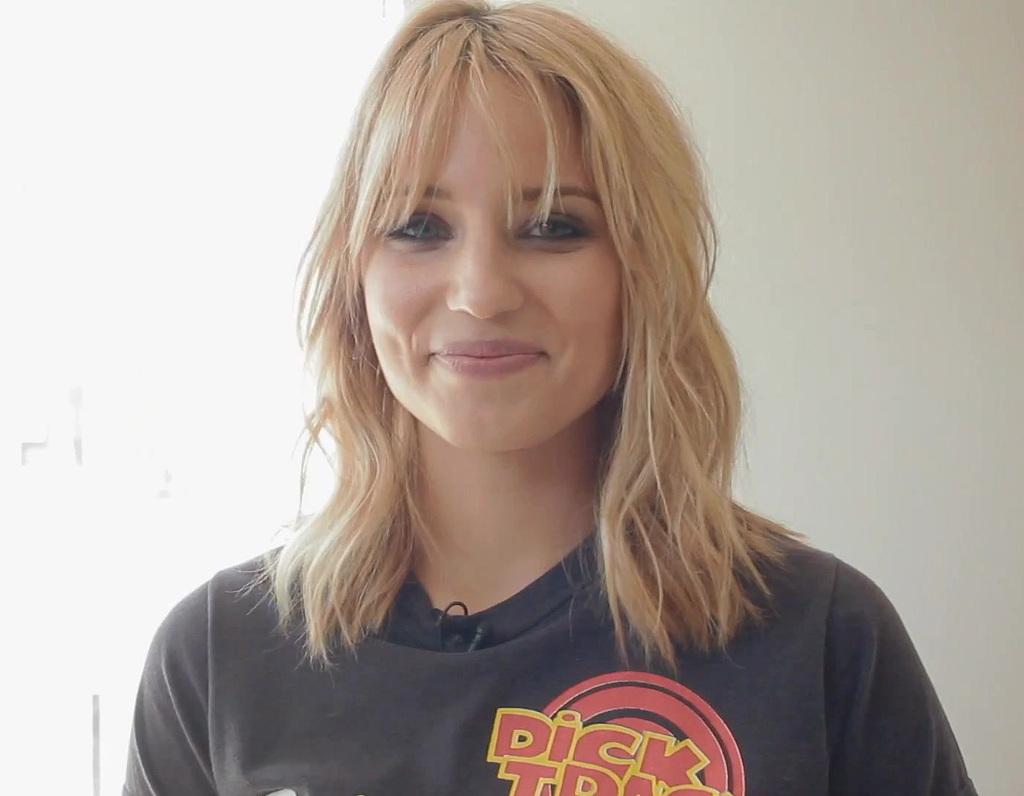What does the girl's shirt say?
Provide a short and direct response. Dick tracy. 